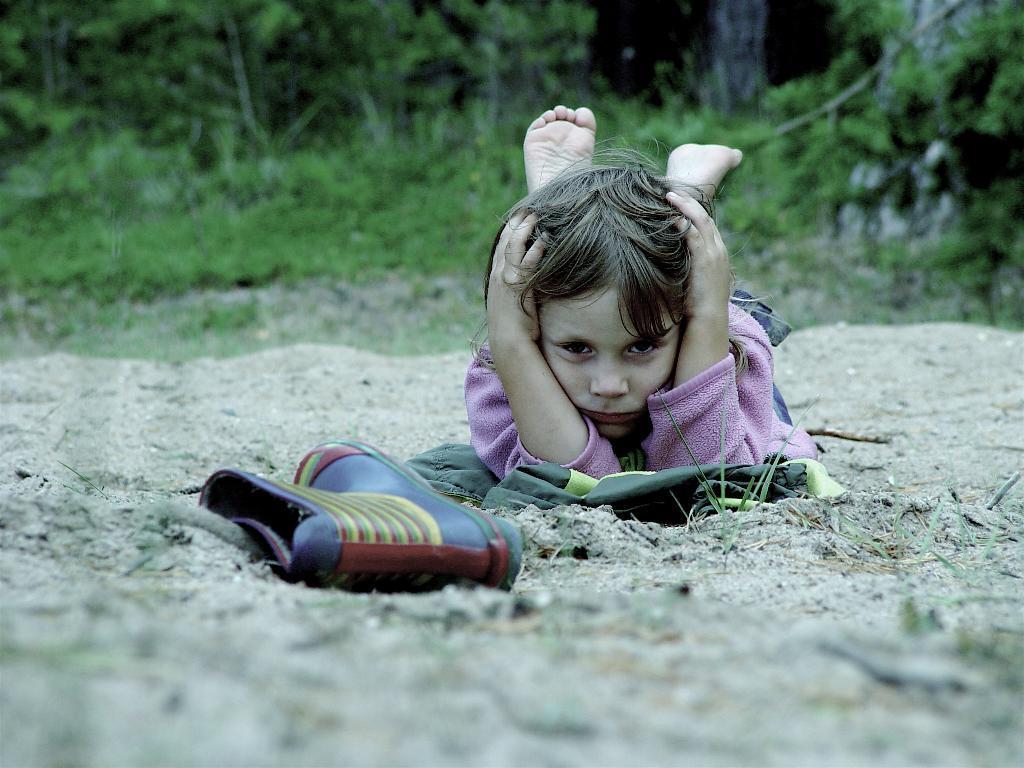In one or two sentences, can you explain what this image depicts? In this image, I can see a shoe and a person lying on the sand. In the background, there are trees and plants. 